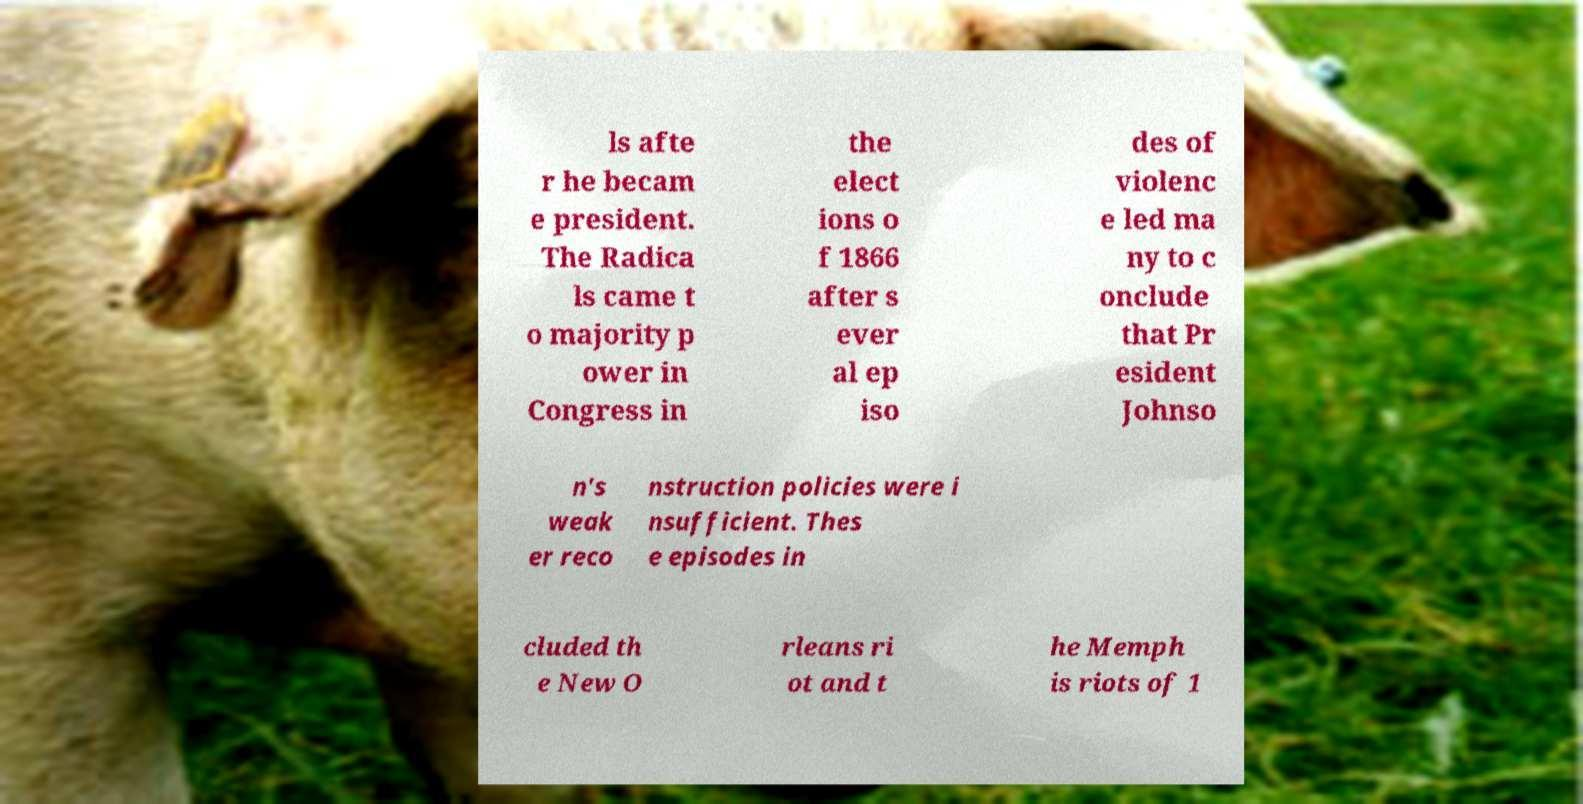Can you accurately transcribe the text from the provided image for me? ls afte r he becam e president. The Radica ls came t o majority p ower in Congress in the elect ions o f 1866 after s ever al ep iso des of violenc e led ma ny to c onclude that Pr esident Johnso n's weak er reco nstruction policies were i nsufficient. Thes e episodes in cluded th e New O rleans ri ot and t he Memph is riots of 1 